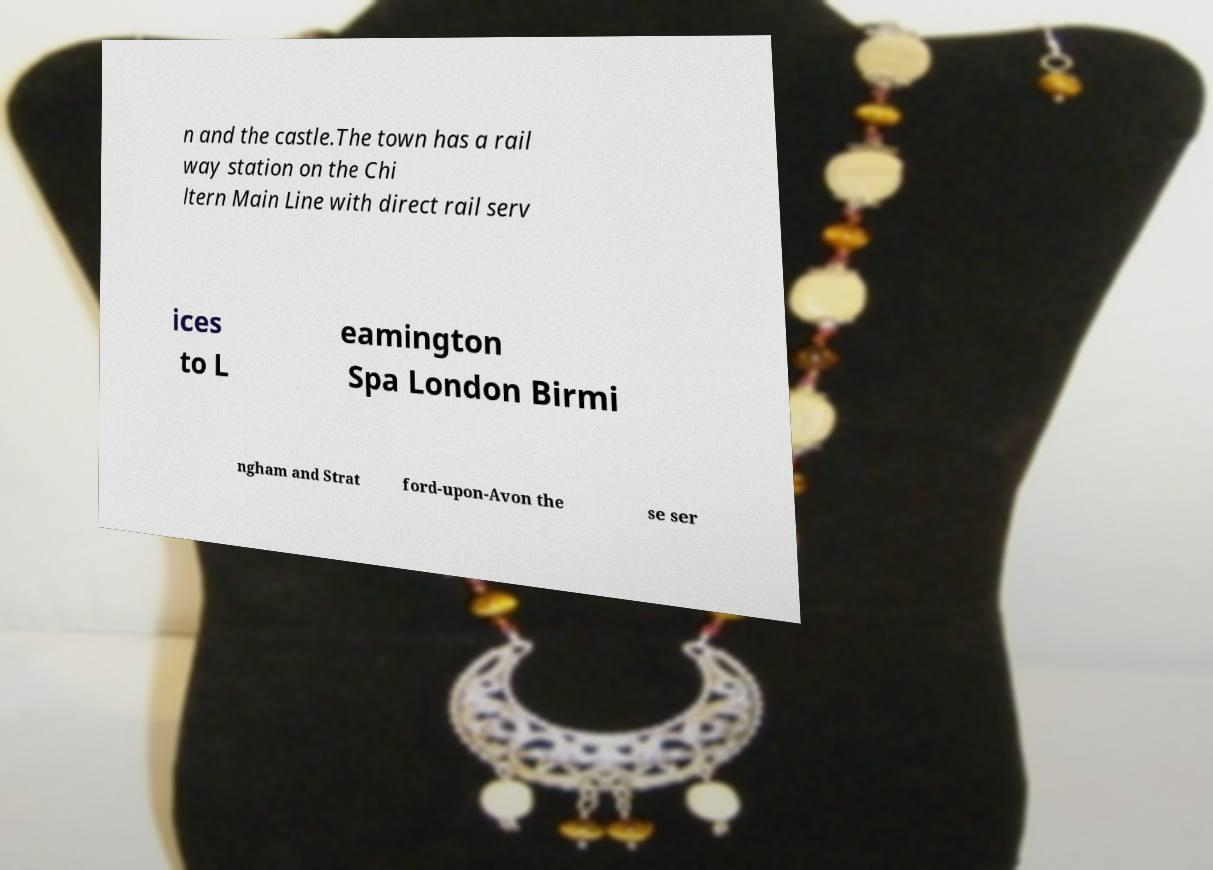For documentation purposes, I need the text within this image transcribed. Could you provide that? n and the castle.The town has a rail way station on the Chi ltern Main Line with direct rail serv ices to L eamington Spa London Birmi ngham and Strat ford-upon-Avon the se ser 